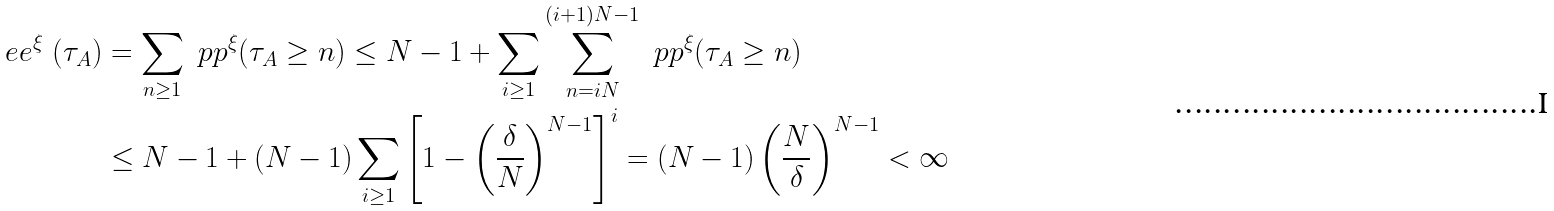<formula> <loc_0><loc_0><loc_500><loc_500>\ e e ^ { \xi } \, \left ( \tau _ { A } \right ) & = \sum _ { n \geq 1 } \ p p ^ { \xi } ( \tau _ { A } \geq n ) \leq N - 1 + \sum _ { i \geq 1 } \sum _ { n = i N } ^ { ( i + 1 ) N - 1 } \ p p ^ { \xi } ( \tau _ { A } \geq n ) \\ & \leq N - 1 + ( N - 1 ) \sum _ { i \geq 1 } \left [ 1 - \left ( \frac { \delta } { N } \right ) ^ { N - 1 } \right ] ^ { i } = ( N - 1 ) \left ( \frac { N } { \delta } \right ) ^ { N - 1 } < \infty</formula> 